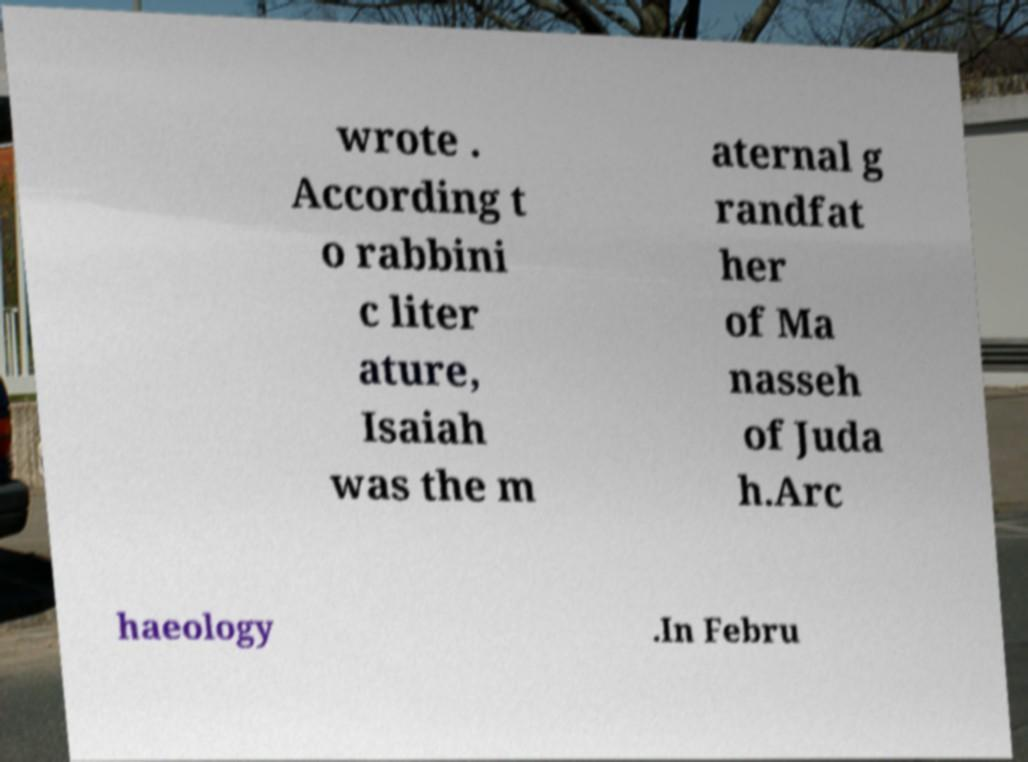Could you extract and type out the text from this image? wrote . According t o rabbini c liter ature, Isaiah was the m aternal g randfat her of Ma nasseh of Juda h.Arc haeology .In Febru 